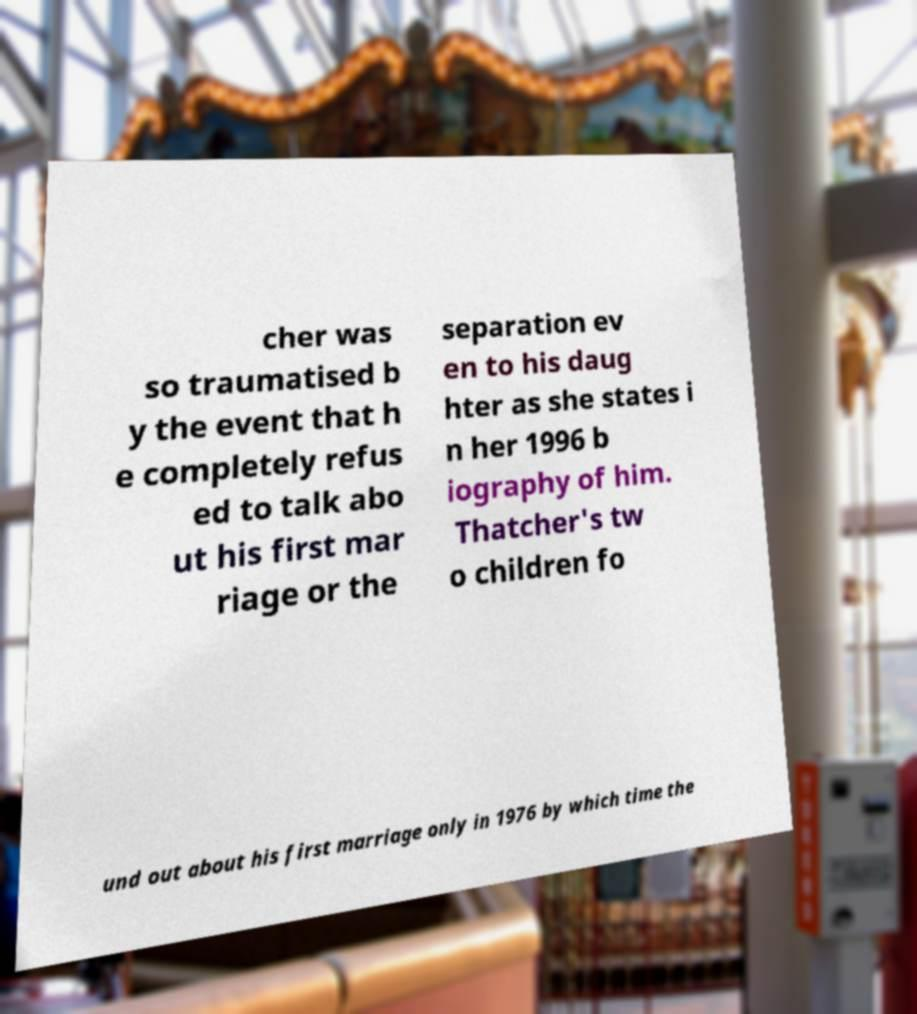Please identify and transcribe the text found in this image. cher was so traumatised b y the event that h e completely refus ed to talk abo ut his first mar riage or the separation ev en to his daug hter as she states i n her 1996 b iography of him. Thatcher's tw o children fo und out about his first marriage only in 1976 by which time the 